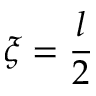Convert formula to latex. <formula><loc_0><loc_0><loc_500><loc_500>\xi = \frac { l } { 2 }</formula> 